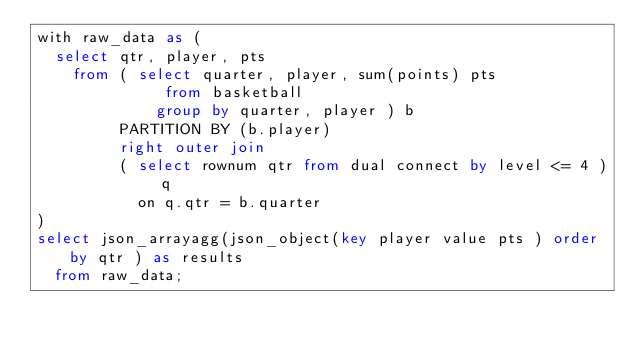Convert code to text. <code><loc_0><loc_0><loc_500><loc_500><_SQL_>with raw_data as (
  select qtr, player, pts
    from ( select quarter, player, sum(points) pts
              from basketball
             group by quarter, player ) b
         PARTITION BY (b.player)
         right outer join
         ( select rownum qtr from dual connect by level <= 4 ) q
           on q.qtr = b.quarter
)
select json_arrayagg(json_object(key player value pts ) order by qtr ) as results
  from raw_data;
</code> 